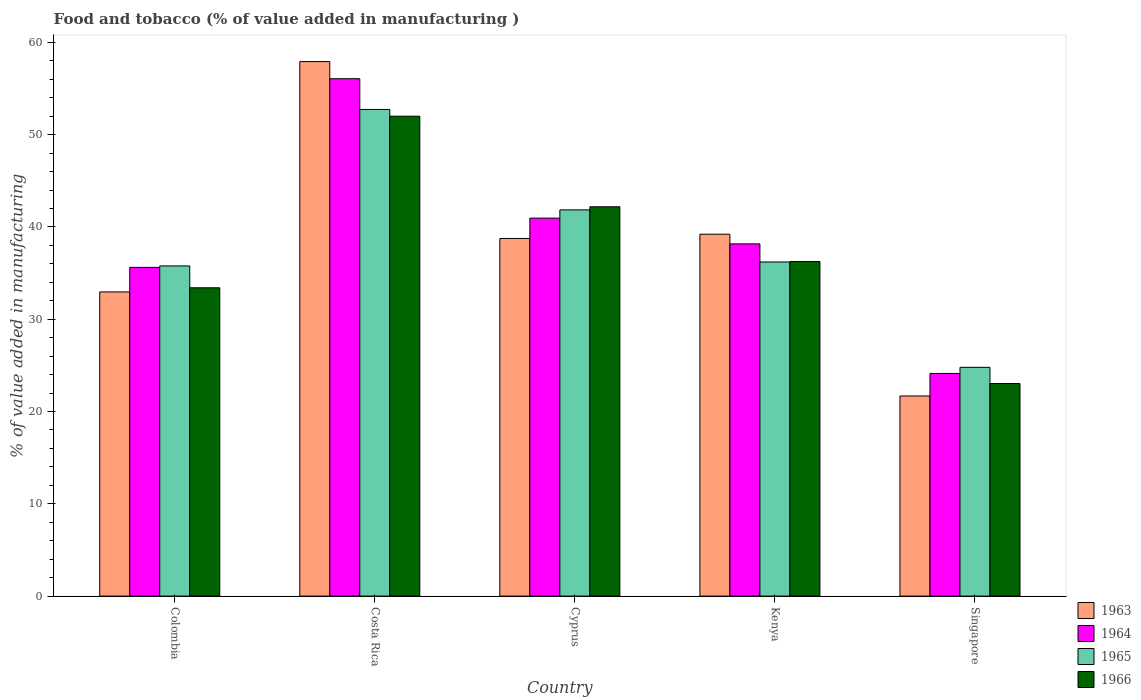How many different coloured bars are there?
Ensure brevity in your answer.  4. How many groups of bars are there?
Offer a terse response. 5. How many bars are there on the 5th tick from the left?
Make the answer very short. 4. What is the label of the 4th group of bars from the left?
Give a very brief answer. Kenya. In how many cases, is the number of bars for a given country not equal to the number of legend labels?
Your response must be concise. 0. What is the value added in manufacturing food and tobacco in 1964 in Singapore?
Your answer should be very brief. 24.13. Across all countries, what is the maximum value added in manufacturing food and tobacco in 1965?
Offer a very short reply. 52.73. Across all countries, what is the minimum value added in manufacturing food and tobacco in 1964?
Keep it short and to the point. 24.13. In which country was the value added in manufacturing food and tobacco in 1963 maximum?
Your answer should be compact. Costa Rica. In which country was the value added in manufacturing food and tobacco in 1966 minimum?
Give a very brief answer. Singapore. What is the total value added in manufacturing food and tobacco in 1964 in the graph?
Provide a succinct answer. 194.94. What is the difference between the value added in manufacturing food and tobacco in 1966 in Colombia and that in Kenya?
Make the answer very short. -2.84. What is the difference between the value added in manufacturing food and tobacco in 1966 in Singapore and the value added in manufacturing food and tobacco in 1965 in Kenya?
Give a very brief answer. -13.17. What is the average value added in manufacturing food and tobacco in 1966 per country?
Provide a succinct answer. 37.38. What is the difference between the value added in manufacturing food and tobacco of/in 1963 and value added in manufacturing food and tobacco of/in 1964 in Singapore?
Give a very brief answer. -2.44. In how many countries, is the value added in manufacturing food and tobacco in 1964 greater than 24 %?
Make the answer very short. 5. What is the ratio of the value added in manufacturing food and tobacco in 1963 in Kenya to that in Singapore?
Your response must be concise. 1.81. Is the difference between the value added in manufacturing food and tobacco in 1963 in Costa Rica and Kenya greater than the difference between the value added in manufacturing food and tobacco in 1964 in Costa Rica and Kenya?
Offer a very short reply. Yes. What is the difference between the highest and the second highest value added in manufacturing food and tobacco in 1964?
Your response must be concise. 15.11. What is the difference between the highest and the lowest value added in manufacturing food and tobacco in 1966?
Keep it short and to the point. 28.97. Is the sum of the value added in manufacturing food and tobacco in 1966 in Kenya and Singapore greater than the maximum value added in manufacturing food and tobacco in 1963 across all countries?
Make the answer very short. Yes. What does the 3rd bar from the left in Costa Rica represents?
Offer a terse response. 1965. What does the 1st bar from the right in Singapore represents?
Provide a succinct answer. 1966. How many bars are there?
Provide a succinct answer. 20. Does the graph contain any zero values?
Provide a short and direct response. No. How many legend labels are there?
Make the answer very short. 4. How are the legend labels stacked?
Make the answer very short. Vertical. What is the title of the graph?
Your answer should be very brief. Food and tobacco (% of value added in manufacturing ). What is the label or title of the X-axis?
Ensure brevity in your answer.  Country. What is the label or title of the Y-axis?
Your answer should be compact. % of value added in manufacturing. What is the % of value added in manufacturing of 1963 in Colombia?
Ensure brevity in your answer.  32.96. What is the % of value added in manufacturing in 1964 in Colombia?
Offer a very short reply. 35.62. What is the % of value added in manufacturing in 1965 in Colombia?
Ensure brevity in your answer.  35.78. What is the % of value added in manufacturing of 1966 in Colombia?
Provide a succinct answer. 33.41. What is the % of value added in manufacturing of 1963 in Costa Rica?
Give a very brief answer. 57.92. What is the % of value added in manufacturing of 1964 in Costa Rica?
Give a very brief answer. 56.07. What is the % of value added in manufacturing in 1965 in Costa Rica?
Offer a very short reply. 52.73. What is the % of value added in manufacturing of 1966 in Costa Rica?
Offer a terse response. 52. What is the % of value added in manufacturing in 1963 in Cyprus?
Provide a short and direct response. 38.75. What is the % of value added in manufacturing in 1964 in Cyprus?
Your answer should be very brief. 40.96. What is the % of value added in manufacturing in 1965 in Cyprus?
Give a very brief answer. 41.85. What is the % of value added in manufacturing in 1966 in Cyprus?
Your answer should be compact. 42.19. What is the % of value added in manufacturing in 1963 in Kenya?
Offer a very short reply. 39.22. What is the % of value added in manufacturing in 1964 in Kenya?
Make the answer very short. 38.17. What is the % of value added in manufacturing in 1965 in Kenya?
Give a very brief answer. 36.2. What is the % of value added in manufacturing of 1966 in Kenya?
Ensure brevity in your answer.  36.25. What is the % of value added in manufacturing in 1963 in Singapore?
Offer a very short reply. 21.69. What is the % of value added in manufacturing in 1964 in Singapore?
Your response must be concise. 24.13. What is the % of value added in manufacturing of 1965 in Singapore?
Offer a terse response. 24.79. What is the % of value added in manufacturing in 1966 in Singapore?
Your response must be concise. 23.04. Across all countries, what is the maximum % of value added in manufacturing in 1963?
Your answer should be very brief. 57.92. Across all countries, what is the maximum % of value added in manufacturing in 1964?
Ensure brevity in your answer.  56.07. Across all countries, what is the maximum % of value added in manufacturing of 1965?
Your answer should be compact. 52.73. Across all countries, what is the maximum % of value added in manufacturing of 1966?
Your answer should be compact. 52. Across all countries, what is the minimum % of value added in manufacturing of 1963?
Make the answer very short. 21.69. Across all countries, what is the minimum % of value added in manufacturing in 1964?
Offer a terse response. 24.13. Across all countries, what is the minimum % of value added in manufacturing of 1965?
Keep it short and to the point. 24.79. Across all countries, what is the minimum % of value added in manufacturing of 1966?
Ensure brevity in your answer.  23.04. What is the total % of value added in manufacturing in 1963 in the graph?
Your answer should be very brief. 190.54. What is the total % of value added in manufacturing of 1964 in the graph?
Provide a short and direct response. 194.94. What is the total % of value added in manufacturing of 1965 in the graph?
Ensure brevity in your answer.  191.36. What is the total % of value added in manufacturing in 1966 in the graph?
Give a very brief answer. 186.89. What is the difference between the % of value added in manufacturing in 1963 in Colombia and that in Costa Rica?
Provide a succinct answer. -24.96. What is the difference between the % of value added in manufacturing in 1964 in Colombia and that in Costa Rica?
Your answer should be very brief. -20.45. What is the difference between the % of value added in manufacturing in 1965 in Colombia and that in Costa Rica?
Keep it short and to the point. -16.95. What is the difference between the % of value added in manufacturing in 1966 in Colombia and that in Costa Rica?
Your response must be concise. -18.59. What is the difference between the % of value added in manufacturing of 1963 in Colombia and that in Cyprus?
Your answer should be very brief. -5.79. What is the difference between the % of value added in manufacturing in 1964 in Colombia and that in Cyprus?
Make the answer very short. -5.34. What is the difference between the % of value added in manufacturing of 1965 in Colombia and that in Cyprus?
Your response must be concise. -6.07. What is the difference between the % of value added in manufacturing of 1966 in Colombia and that in Cyprus?
Ensure brevity in your answer.  -8.78. What is the difference between the % of value added in manufacturing in 1963 in Colombia and that in Kenya?
Provide a succinct answer. -6.26. What is the difference between the % of value added in manufacturing of 1964 in Colombia and that in Kenya?
Make the answer very short. -2.55. What is the difference between the % of value added in manufacturing in 1965 in Colombia and that in Kenya?
Your response must be concise. -0.42. What is the difference between the % of value added in manufacturing in 1966 in Colombia and that in Kenya?
Give a very brief answer. -2.84. What is the difference between the % of value added in manufacturing of 1963 in Colombia and that in Singapore?
Make the answer very short. 11.27. What is the difference between the % of value added in manufacturing in 1964 in Colombia and that in Singapore?
Your answer should be compact. 11.49. What is the difference between the % of value added in manufacturing of 1965 in Colombia and that in Singapore?
Provide a short and direct response. 10.99. What is the difference between the % of value added in manufacturing of 1966 in Colombia and that in Singapore?
Give a very brief answer. 10.37. What is the difference between the % of value added in manufacturing in 1963 in Costa Rica and that in Cyprus?
Offer a very short reply. 19.17. What is the difference between the % of value added in manufacturing of 1964 in Costa Rica and that in Cyprus?
Your response must be concise. 15.11. What is the difference between the % of value added in manufacturing of 1965 in Costa Rica and that in Cyprus?
Offer a very short reply. 10.88. What is the difference between the % of value added in manufacturing of 1966 in Costa Rica and that in Cyprus?
Offer a terse response. 9.82. What is the difference between the % of value added in manufacturing in 1963 in Costa Rica and that in Kenya?
Your answer should be compact. 18.7. What is the difference between the % of value added in manufacturing in 1964 in Costa Rica and that in Kenya?
Ensure brevity in your answer.  17.9. What is the difference between the % of value added in manufacturing in 1965 in Costa Rica and that in Kenya?
Provide a succinct answer. 16.53. What is the difference between the % of value added in manufacturing in 1966 in Costa Rica and that in Kenya?
Offer a terse response. 15.75. What is the difference between the % of value added in manufacturing of 1963 in Costa Rica and that in Singapore?
Offer a very short reply. 36.23. What is the difference between the % of value added in manufacturing of 1964 in Costa Rica and that in Singapore?
Offer a terse response. 31.94. What is the difference between the % of value added in manufacturing of 1965 in Costa Rica and that in Singapore?
Your answer should be compact. 27.94. What is the difference between the % of value added in manufacturing of 1966 in Costa Rica and that in Singapore?
Offer a terse response. 28.97. What is the difference between the % of value added in manufacturing of 1963 in Cyprus and that in Kenya?
Give a very brief answer. -0.46. What is the difference between the % of value added in manufacturing of 1964 in Cyprus and that in Kenya?
Keep it short and to the point. 2.79. What is the difference between the % of value added in manufacturing of 1965 in Cyprus and that in Kenya?
Give a very brief answer. 5.65. What is the difference between the % of value added in manufacturing in 1966 in Cyprus and that in Kenya?
Make the answer very short. 5.93. What is the difference between the % of value added in manufacturing of 1963 in Cyprus and that in Singapore?
Give a very brief answer. 17.07. What is the difference between the % of value added in manufacturing in 1964 in Cyprus and that in Singapore?
Provide a succinct answer. 16.83. What is the difference between the % of value added in manufacturing of 1965 in Cyprus and that in Singapore?
Ensure brevity in your answer.  17.06. What is the difference between the % of value added in manufacturing of 1966 in Cyprus and that in Singapore?
Make the answer very short. 19.15. What is the difference between the % of value added in manufacturing in 1963 in Kenya and that in Singapore?
Provide a succinct answer. 17.53. What is the difference between the % of value added in manufacturing of 1964 in Kenya and that in Singapore?
Provide a short and direct response. 14.04. What is the difference between the % of value added in manufacturing in 1965 in Kenya and that in Singapore?
Your response must be concise. 11.41. What is the difference between the % of value added in manufacturing in 1966 in Kenya and that in Singapore?
Make the answer very short. 13.22. What is the difference between the % of value added in manufacturing in 1963 in Colombia and the % of value added in manufacturing in 1964 in Costa Rica?
Provide a succinct answer. -23.11. What is the difference between the % of value added in manufacturing in 1963 in Colombia and the % of value added in manufacturing in 1965 in Costa Rica?
Provide a short and direct response. -19.77. What is the difference between the % of value added in manufacturing in 1963 in Colombia and the % of value added in manufacturing in 1966 in Costa Rica?
Your answer should be very brief. -19.04. What is the difference between the % of value added in manufacturing in 1964 in Colombia and the % of value added in manufacturing in 1965 in Costa Rica?
Your response must be concise. -17.11. What is the difference between the % of value added in manufacturing of 1964 in Colombia and the % of value added in manufacturing of 1966 in Costa Rica?
Make the answer very short. -16.38. What is the difference between the % of value added in manufacturing in 1965 in Colombia and the % of value added in manufacturing in 1966 in Costa Rica?
Your response must be concise. -16.22. What is the difference between the % of value added in manufacturing in 1963 in Colombia and the % of value added in manufacturing in 1964 in Cyprus?
Provide a short and direct response. -8. What is the difference between the % of value added in manufacturing of 1963 in Colombia and the % of value added in manufacturing of 1965 in Cyprus?
Provide a succinct answer. -8.89. What is the difference between the % of value added in manufacturing of 1963 in Colombia and the % of value added in manufacturing of 1966 in Cyprus?
Keep it short and to the point. -9.23. What is the difference between the % of value added in manufacturing in 1964 in Colombia and the % of value added in manufacturing in 1965 in Cyprus?
Provide a succinct answer. -6.23. What is the difference between the % of value added in manufacturing of 1964 in Colombia and the % of value added in manufacturing of 1966 in Cyprus?
Keep it short and to the point. -6.57. What is the difference between the % of value added in manufacturing of 1965 in Colombia and the % of value added in manufacturing of 1966 in Cyprus?
Provide a succinct answer. -6.41. What is the difference between the % of value added in manufacturing of 1963 in Colombia and the % of value added in manufacturing of 1964 in Kenya?
Make the answer very short. -5.21. What is the difference between the % of value added in manufacturing in 1963 in Colombia and the % of value added in manufacturing in 1965 in Kenya?
Your answer should be compact. -3.24. What is the difference between the % of value added in manufacturing of 1963 in Colombia and the % of value added in manufacturing of 1966 in Kenya?
Ensure brevity in your answer.  -3.29. What is the difference between the % of value added in manufacturing in 1964 in Colombia and the % of value added in manufacturing in 1965 in Kenya?
Your answer should be very brief. -0.58. What is the difference between the % of value added in manufacturing in 1964 in Colombia and the % of value added in manufacturing in 1966 in Kenya?
Make the answer very short. -0.63. What is the difference between the % of value added in manufacturing of 1965 in Colombia and the % of value added in manufacturing of 1966 in Kenya?
Your response must be concise. -0.47. What is the difference between the % of value added in manufacturing of 1963 in Colombia and the % of value added in manufacturing of 1964 in Singapore?
Make the answer very short. 8.83. What is the difference between the % of value added in manufacturing of 1963 in Colombia and the % of value added in manufacturing of 1965 in Singapore?
Give a very brief answer. 8.17. What is the difference between the % of value added in manufacturing of 1963 in Colombia and the % of value added in manufacturing of 1966 in Singapore?
Provide a succinct answer. 9.92. What is the difference between the % of value added in manufacturing in 1964 in Colombia and the % of value added in manufacturing in 1965 in Singapore?
Ensure brevity in your answer.  10.83. What is the difference between the % of value added in manufacturing of 1964 in Colombia and the % of value added in manufacturing of 1966 in Singapore?
Provide a short and direct response. 12.58. What is the difference between the % of value added in manufacturing of 1965 in Colombia and the % of value added in manufacturing of 1966 in Singapore?
Make the answer very short. 12.74. What is the difference between the % of value added in manufacturing in 1963 in Costa Rica and the % of value added in manufacturing in 1964 in Cyprus?
Your answer should be compact. 16.96. What is the difference between the % of value added in manufacturing in 1963 in Costa Rica and the % of value added in manufacturing in 1965 in Cyprus?
Your answer should be compact. 16.07. What is the difference between the % of value added in manufacturing in 1963 in Costa Rica and the % of value added in manufacturing in 1966 in Cyprus?
Your answer should be very brief. 15.73. What is the difference between the % of value added in manufacturing of 1964 in Costa Rica and the % of value added in manufacturing of 1965 in Cyprus?
Provide a succinct answer. 14.21. What is the difference between the % of value added in manufacturing of 1964 in Costa Rica and the % of value added in manufacturing of 1966 in Cyprus?
Your answer should be very brief. 13.88. What is the difference between the % of value added in manufacturing of 1965 in Costa Rica and the % of value added in manufacturing of 1966 in Cyprus?
Provide a succinct answer. 10.55. What is the difference between the % of value added in manufacturing of 1963 in Costa Rica and the % of value added in manufacturing of 1964 in Kenya?
Offer a terse response. 19.75. What is the difference between the % of value added in manufacturing of 1963 in Costa Rica and the % of value added in manufacturing of 1965 in Kenya?
Provide a succinct answer. 21.72. What is the difference between the % of value added in manufacturing in 1963 in Costa Rica and the % of value added in manufacturing in 1966 in Kenya?
Your answer should be very brief. 21.67. What is the difference between the % of value added in manufacturing of 1964 in Costa Rica and the % of value added in manufacturing of 1965 in Kenya?
Give a very brief answer. 19.86. What is the difference between the % of value added in manufacturing of 1964 in Costa Rica and the % of value added in manufacturing of 1966 in Kenya?
Offer a terse response. 19.81. What is the difference between the % of value added in manufacturing of 1965 in Costa Rica and the % of value added in manufacturing of 1966 in Kenya?
Your answer should be very brief. 16.48. What is the difference between the % of value added in manufacturing of 1963 in Costa Rica and the % of value added in manufacturing of 1964 in Singapore?
Make the answer very short. 33.79. What is the difference between the % of value added in manufacturing in 1963 in Costa Rica and the % of value added in manufacturing in 1965 in Singapore?
Provide a short and direct response. 33.13. What is the difference between the % of value added in manufacturing in 1963 in Costa Rica and the % of value added in manufacturing in 1966 in Singapore?
Your answer should be very brief. 34.88. What is the difference between the % of value added in manufacturing of 1964 in Costa Rica and the % of value added in manufacturing of 1965 in Singapore?
Ensure brevity in your answer.  31.28. What is the difference between the % of value added in manufacturing of 1964 in Costa Rica and the % of value added in manufacturing of 1966 in Singapore?
Your answer should be very brief. 33.03. What is the difference between the % of value added in manufacturing of 1965 in Costa Rica and the % of value added in manufacturing of 1966 in Singapore?
Give a very brief answer. 29.7. What is the difference between the % of value added in manufacturing of 1963 in Cyprus and the % of value added in manufacturing of 1964 in Kenya?
Offer a terse response. 0.59. What is the difference between the % of value added in manufacturing of 1963 in Cyprus and the % of value added in manufacturing of 1965 in Kenya?
Give a very brief answer. 2.55. What is the difference between the % of value added in manufacturing of 1963 in Cyprus and the % of value added in manufacturing of 1966 in Kenya?
Make the answer very short. 2.5. What is the difference between the % of value added in manufacturing in 1964 in Cyprus and the % of value added in manufacturing in 1965 in Kenya?
Provide a short and direct response. 4.75. What is the difference between the % of value added in manufacturing of 1964 in Cyprus and the % of value added in manufacturing of 1966 in Kenya?
Your answer should be compact. 4.7. What is the difference between the % of value added in manufacturing in 1965 in Cyprus and the % of value added in manufacturing in 1966 in Kenya?
Offer a terse response. 5.6. What is the difference between the % of value added in manufacturing in 1963 in Cyprus and the % of value added in manufacturing in 1964 in Singapore?
Make the answer very short. 14.63. What is the difference between the % of value added in manufacturing of 1963 in Cyprus and the % of value added in manufacturing of 1965 in Singapore?
Your answer should be very brief. 13.96. What is the difference between the % of value added in manufacturing of 1963 in Cyprus and the % of value added in manufacturing of 1966 in Singapore?
Provide a short and direct response. 15.72. What is the difference between the % of value added in manufacturing of 1964 in Cyprus and the % of value added in manufacturing of 1965 in Singapore?
Keep it short and to the point. 16.17. What is the difference between the % of value added in manufacturing in 1964 in Cyprus and the % of value added in manufacturing in 1966 in Singapore?
Keep it short and to the point. 17.92. What is the difference between the % of value added in manufacturing in 1965 in Cyprus and the % of value added in manufacturing in 1966 in Singapore?
Ensure brevity in your answer.  18.82. What is the difference between the % of value added in manufacturing of 1963 in Kenya and the % of value added in manufacturing of 1964 in Singapore?
Your response must be concise. 15.09. What is the difference between the % of value added in manufacturing in 1963 in Kenya and the % of value added in manufacturing in 1965 in Singapore?
Offer a terse response. 14.43. What is the difference between the % of value added in manufacturing of 1963 in Kenya and the % of value added in manufacturing of 1966 in Singapore?
Offer a very short reply. 16.18. What is the difference between the % of value added in manufacturing of 1964 in Kenya and the % of value added in manufacturing of 1965 in Singapore?
Offer a terse response. 13.38. What is the difference between the % of value added in manufacturing of 1964 in Kenya and the % of value added in manufacturing of 1966 in Singapore?
Keep it short and to the point. 15.13. What is the difference between the % of value added in manufacturing of 1965 in Kenya and the % of value added in manufacturing of 1966 in Singapore?
Provide a succinct answer. 13.17. What is the average % of value added in manufacturing in 1963 per country?
Ensure brevity in your answer.  38.11. What is the average % of value added in manufacturing in 1964 per country?
Offer a very short reply. 38.99. What is the average % of value added in manufacturing of 1965 per country?
Provide a short and direct response. 38.27. What is the average % of value added in manufacturing of 1966 per country?
Your answer should be very brief. 37.38. What is the difference between the % of value added in manufacturing of 1963 and % of value added in manufacturing of 1964 in Colombia?
Give a very brief answer. -2.66. What is the difference between the % of value added in manufacturing of 1963 and % of value added in manufacturing of 1965 in Colombia?
Make the answer very short. -2.82. What is the difference between the % of value added in manufacturing in 1963 and % of value added in manufacturing in 1966 in Colombia?
Give a very brief answer. -0.45. What is the difference between the % of value added in manufacturing in 1964 and % of value added in manufacturing in 1965 in Colombia?
Offer a very short reply. -0.16. What is the difference between the % of value added in manufacturing in 1964 and % of value added in manufacturing in 1966 in Colombia?
Make the answer very short. 2.21. What is the difference between the % of value added in manufacturing of 1965 and % of value added in manufacturing of 1966 in Colombia?
Your answer should be very brief. 2.37. What is the difference between the % of value added in manufacturing of 1963 and % of value added in manufacturing of 1964 in Costa Rica?
Your answer should be very brief. 1.85. What is the difference between the % of value added in manufacturing in 1963 and % of value added in manufacturing in 1965 in Costa Rica?
Your answer should be very brief. 5.19. What is the difference between the % of value added in manufacturing in 1963 and % of value added in manufacturing in 1966 in Costa Rica?
Keep it short and to the point. 5.92. What is the difference between the % of value added in manufacturing in 1964 and % of value added in manufacturing in 1965 in Costa Rica?
Your answer should be compact. 3.33. What is the difference between the % of value added in manufacturing of 1964 and % of value added in manufacturing of 1966 in Costa Rica?
Keep it short and to the point. 4.06. What is the difference between the % of value added in manufacturing in 1965 and % of value added in manufacturing in 1966 in Costa Rica?
Your response must be concise. 0.73. What is the difference between the % of value added in manufacturing of 1963 and % of value added in manufacturing of 1964 in Cyprus?
Make the answer very short. -2.2. What is the difference between the % of value added in manufacturing in 1963 and % of value added in manufacturing in 1965 in Cyprus?
Offer a terse response. -3.1. What is the difference between the % of value added in manufacturing in 1963 and % of value added in manufacturing in 1966 in Cyprus?
Keep it short and to the point. -3.43. What is the difference between the % of value added in manufacturing in 1964 and % of value added in manufacturing in 1965 in Cyprus?
Offer a very short reply. -0.9. What is the difference between the % of value added in manufacturing in 1964 and % of value added in manufacturing in 1966 in Cyprus?
Offer a terse response. -1.23. What is the difference between the % of value added in manufacturing in 1965 and % of value added in manufacturing in 1966 in Cyprus?
Ensure brevity in your answer.  -0.33. What is the difference between the % of value added in manufacturing of 1963 and % of value added in manufacturing of 1964 in Kenya?
Offer a terse response. 1.05. What is the difference between the % of value added in manufacturing in 1963 and % of value added in manufacturing in 1965 in Kenya?
Offer a terse response. 3.01. What is the difference between the % of value added in manufacturing in 1963 and % of value added in manufacturing in 1966 in Kenya?
Offer a terse response. 2.96. What is the difference between the % of value added in manufacturing in 1964 and % of value added in manufacturing in 1965 in Kenya?
Give a very brief answer. 1.96. What is the difference between the % of value added in manufacturing of 1964 and % of value added in manufacturing of 1966 in Kenya?
Your answer should be compact. 1.91. What is the difference between the % of value added in manufacturing in 1965 and % of value added in manufacturing in 1966 in Kenya?
Provide a succinct answer. -0.05. What is the difference between the % of value added in manufacturing of 1963 and % of value added in manufacturing of 1964 in Singapore?
Provide a short and direct response. -2.44. What is the difference between the % of value added in manufacturing of 1963 and % of value added in manufacturing of 1965 in Singapore?
Your answer should be compact. -3.1. What is the difference between the % of value added in manufacturing in 1963 and % of value added in manufacturing in 1966 in Singapore?
Give a very brief answer. -1.35. What is the difference between the % of value added in manufacturing of 1964 and % of value added in manufacturing of 1965 in Singapore?
Keep it short and to the point. -0.66. What is the difference between the % of value added in manufacturing of 1964 and % of value added in manufacturing of 1966 in Singapore?
Give a very brief answer. 1.09. What is the difference between the % of value added in manufacturing in 1965 and % of value added in manufacturing in 1966 in Singapore?
Keep it short and to the point. 1.75. What is the ratio of the % of value added in manufacturing of 1963 in Colombia to that in Costa Rica?
Provide a succinct answer. 0.57. What is the ratio of the % of value added in manufacturing in 1964 in Colombia to that in Costa Rica?
Provide a succinct answer. 0.64. What is the ratio of the % of value added in manufacturing of 1965 in Colombia to that in Costa Rica?
Your answer should be compact. 0.68. What is the ratio of the % of value added in manufacturing of 1966 in Colombia to that in Costa Rica?
Offer a very short reply. 0.64. What is the ratio of the % of value added in manufacturing of 1963 in Colombia to that in Cyprus?
Offer a very short reply. 0.85. What is the ratio of the % of value added in manufacturing of 1964 in Colombia to that in Cyprus?
Provide a short and direct response. 0.87. What is the ratio of the % of value added in manufacturing of 1965 in Colombia to that in Cyprus?
Your answer should be compact. 0.85. What is the ratio of the % of value added in manufacturing in 1966 in Colombia to that in Cyprus?
Make the answer very short. 0.79. What is the ratio of the % of value added in manufacturing of 1963 in Colombia to that in Kenya?
Provide a succinct answer. 0.84. What is the ratio of the % of value added in manufacturing of 1964 in Colombia to that in Kenya?
Your answer should be compact. 0.93. What is the ratio of the % of value added in manufacturing of 1965 in Colombia to that in Kenya?
Provide a succinct answer. 0.99. What is the ratio of the % of value added in manufacturing in 1966 in Colombia to that in Kenya?
Offer a terse response. 0.92. What is the ratio of the % of value added in manufacturing in 1963 in Colombia to that in Singapore?
Give a very brief answer. 1.52. What is the ratio of the % of value added in manufacturing in 1964 in Colombia to that in Singapore?
Offer a very short reply. 1.48. What is the ratio of the % of value added in manufacturing in 1965 in Colombia to that in Singapore?
Keep it short and to the point. 1.44. What is the ratio of the % of value added in manufacturing in 1966 in Colombia to that in Singapore?
Your response must be concise. 1.45. What is the ratio of the % of value added in manufacturing in 1963 in Costa Rica to that in Cyprus?
Make the answer very short. 1.49. What is the ratio of the % of value added in manufacturing of 1964 in Costa Rica to that in Cyprus?
Keep it short and to the point. 1.37. What is the ratio of the % of value added in manufacturing of 1965 in Costa Rica to that in Cyprus?
Make the answer very short. 1.26. What is the ratio of the % of value added in manufacturing in 1966 in Costa Rica to that in Cyprus?
Your answer should be compact. 1.23. What is the ratio of the % of value added in manufacturing in 1963 in Costa Rica to that in Kenya?
Your answer should be compact. 1.48. What is the ratio of the % of value added in manufacturing in 1964 in Costa Rica to that in Kenya?
Offer a terse response. 1.47. What is the ratio of the % of value added in manufacturing in 1965 in Costa Rica to that in Kenya?
Offer a very short reply. 1.46. What is the ratio of the % of value added in manufacturing in 1966 in Costa Rica to that in Kenya?
Provide a short and direct response. 1.43. What is the ratio of the % of value added in manufacturing in 1963 in Costa Rica to that in Singapore?
Your response must be concise. 2.67. What is the ratio of the % of value added in manufacturing of 1964 in Costa Rica to that in Singapore?
Offer a very short reply. 2.32. What is the ratio of the % of value added in manufacturing of 1965 in Costa Rica to that in Singapore?
Your answer should be compact. 2.13. What is the ratio of the % of value added in manufacturing in 1966 in Costa Rica to that in Singapore?
Ensure brevity in your answer.  2.26. What is the ratio of the % of value added in manufacturing of 1964 in Cyprus to that in Kenya?
Your answer should be very brief. 1.07. What is the ratio of the % of value added in manufacturing of 1965 in Cyprus to that in Kenya?
Give a very brief answer. 1.16. What is the ratio of the % of value added in manufacturing in 1966 in Cyprus to that in Kenya?
Ensure brevity in your answer.  1.16. What is the ratio of the % of value added in manufacturing in 1963 in Cyprus to that in Singapore?
Provide a succinct answer. 1.79. What is the ratio of the % of value added in manufacturing in 1964 in Cyprus to that in Singapore?
Your answer should be very brief. 1.7. What is the ratio of the % of value added in manufacturing in 1965 in Cyprus to that in Singapore?
Offer a terse response. 1.69. What is the ratio of the % of value added in manufacturing of 1966 in Cyprus to that in Singapore?
Make the answer very short. 1.83. What is the ratio of the % of value added in manufacturing in 1963 in Kenya to that in Singapore?
Your response must be concise. 1.81. What is the ratio of the % of value added in manufacturing in 1964 in Kenya to that in Singapore?
Provide a succinct answer. 1.58. What is the ratio of the % of value added in manufacturing of 1965 in Kenya to that in Singapore?
Give a very brief answer. 1.46. What is the ratio of the % of value added in manufacturing in 1966 in Kenya to that in Singapore?
Your answer should be very brief. 1.57. What is the difference between the highest and the second highest % of value added in manufacturing in 1963?
Make the answer very short. 18.7. What is the difference between the highest and the second highest % of value added in manufacturing in 1964?
Your response must be concise. 15.11. What is the difference between the highest and the second highest % of value added in manufacturing of 1965?
Ensure brevity in your answer.  10.88. What is the difference between the highest and the second highest % of value added in manufacturing in 1966?
Your answer should be compact. 9.82. What is the difference between the highest and the lowest % of value added in manufacturing of 1963?
Your response must be concise. 36.23. What is the difference between the highest and the lowest % of value added in manufacturing of 1964?
Your response must be concise. 31.94. What is the difference between the highest and the lowest % of value added in manufacturing of 1965?
Your answer should be very brief. 27.94. What is the difference between the highest and the lowest % of value added in manufacturing in 1966?
Make the answer very short. 28.97. 